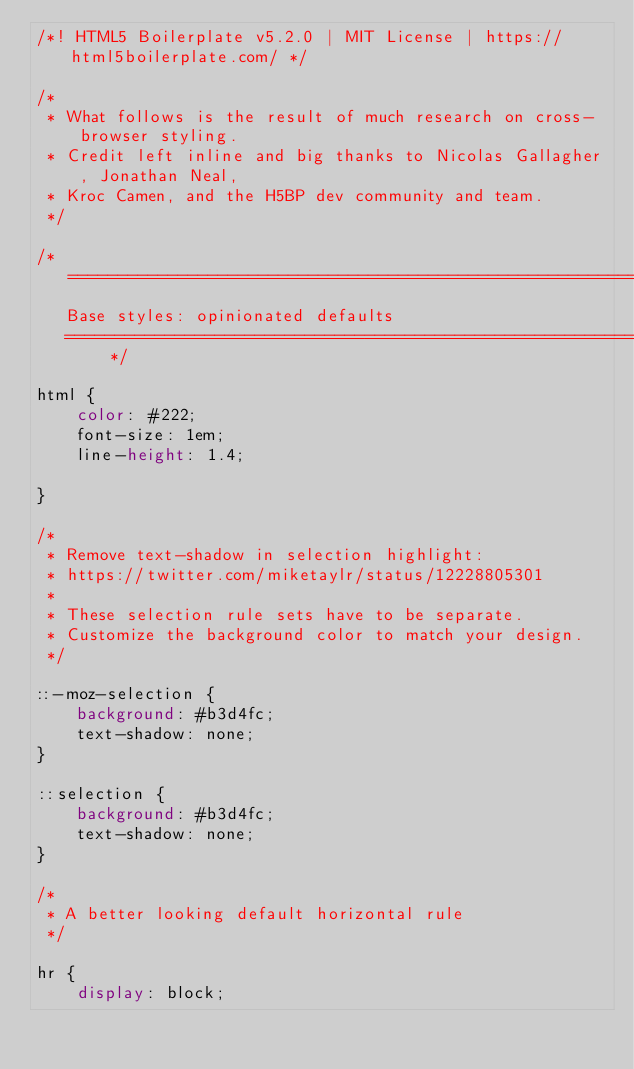<code> <loc_0><loc_0><loc_500><loc_500><_CSS_>/*! HTML5 Boilerplate v5.2.0 | MIT License | https://html5boilerplate.com/ */

/*
 * What follows is the result of much research on cross-browser styling.
 * Credit left inline and big thanks to Nicolas Gallagher, Jonathan Neal,
 * Kroc Camen, and the H5BP dev community and team.
 */

/* ==========================================================================
   Base styles: opinionated defaults
   ========================================================================== */

html {
    color: #222;
    font-size: 1em;
    line-height: 1.4;

}

/*
 * Remove text-shadow in selection highlight:
 * https://twitter.com/miketaylr/status/12228805301
 *
 * These selection rule sets have to be separate.
 * Customize the background color to match your design.
 */

::-moz-selection {
    background: #b3d4fc;
    text-shadow: none;
}

::selection {
    background: #b3d4fc;
    text-shadow: none;
}

/*
 * A better looking default horizontal rule
 */

hr {
    display: block;</code> 